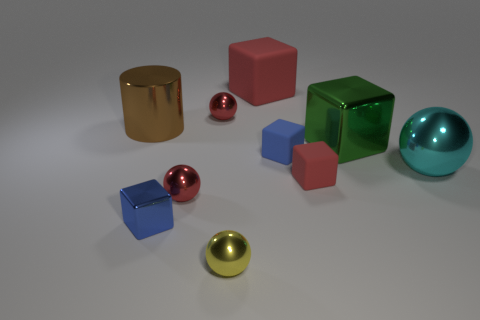There is a small yellow shiny thing; is it the same shape as the metal thing that is on the right side of the big shiny cube? Yes, the small yellow object is spherical, sharing the same shape as the metal ball positioned to the right of the large, reflective cube. Both exhibit a high-gloss finish that reflects the light, underscoring their similar geometric form. 